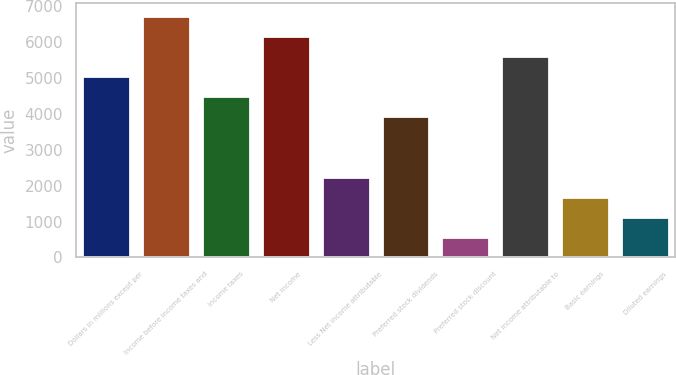<chart> <loc_0><loc_0><loc_500><loc_500><bar_chart><fcel>Dollars in millions except per<fcel>Income before income taxes and<fcel>Income taxes<fcel>Net income<fcel>Less Net income attributable<fcel>Preferred stock dividends<fcel>Preferred stock discount<fcel>Net income attributable to<fcel>Basic earnings<fcel>Diluted earnings<nl><fcel>5052.77<fcel>6736.4<fcel>4491.56<fcel>6175.19<fcel>2246.72<fcel>3930.35<fcel>563.09<fcel>5613.98<fcel>1685.51<fcel>1124.3<nl></chart> 